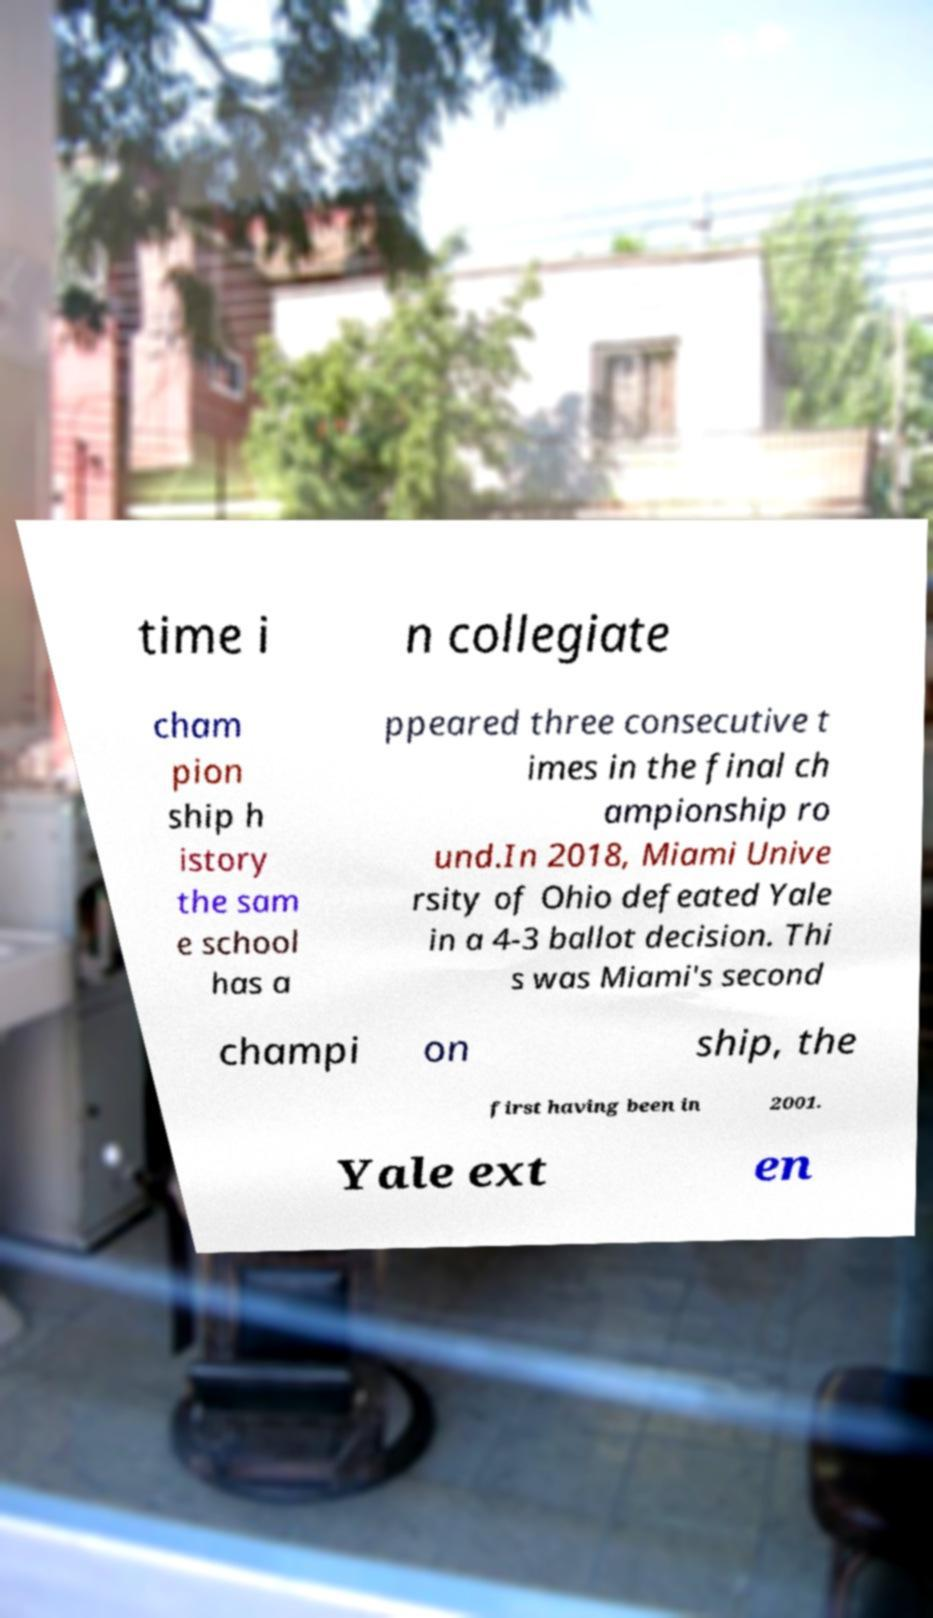What messages or text are displayed in this image? I need them in a readable, typed format. time i n collegiate cham pion ship h istory the sam e school has a ppeared three consecutive t imes in the final ch ampionship ro und.In 2018, Miami Unive rsity of Ohio defeated Yale in a 4-3 ballot decision. Thi s was Miami's second champi on ship, the first having been in 2001. Yale ext en 